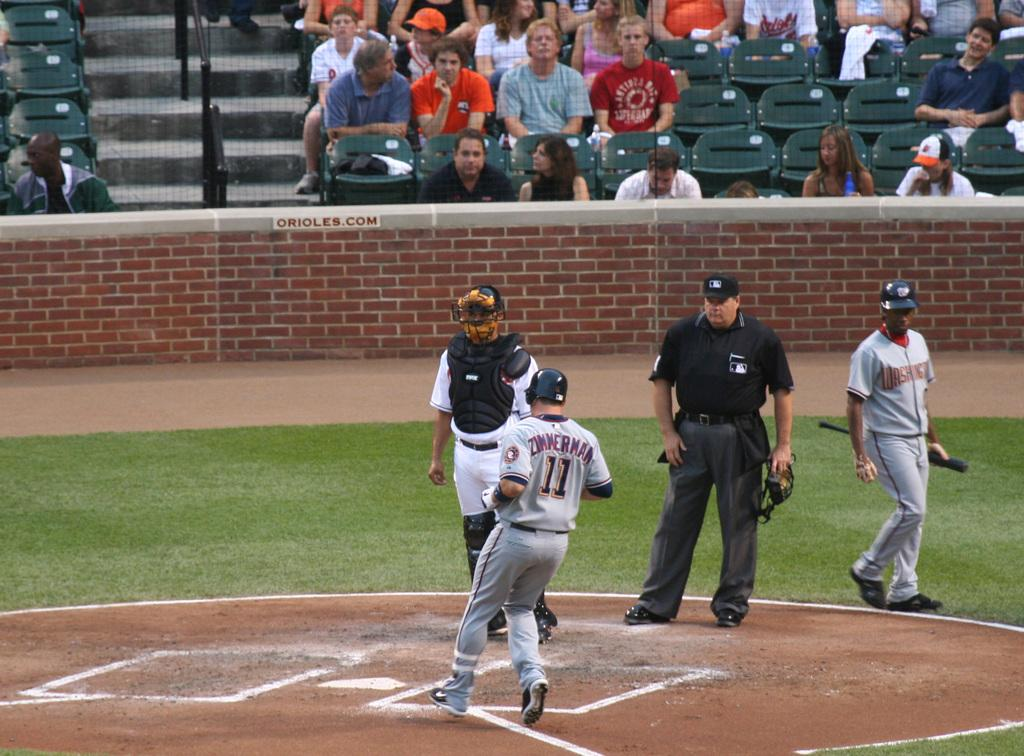<image>
Render a clear and concise summary of the photo. A picture of the Washington player Zimmerman, number 11 heading into home plate. 